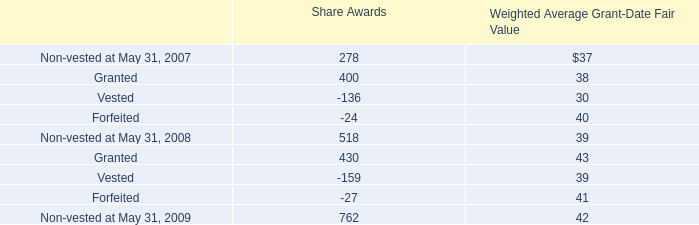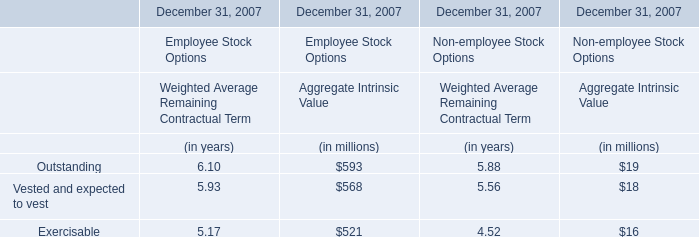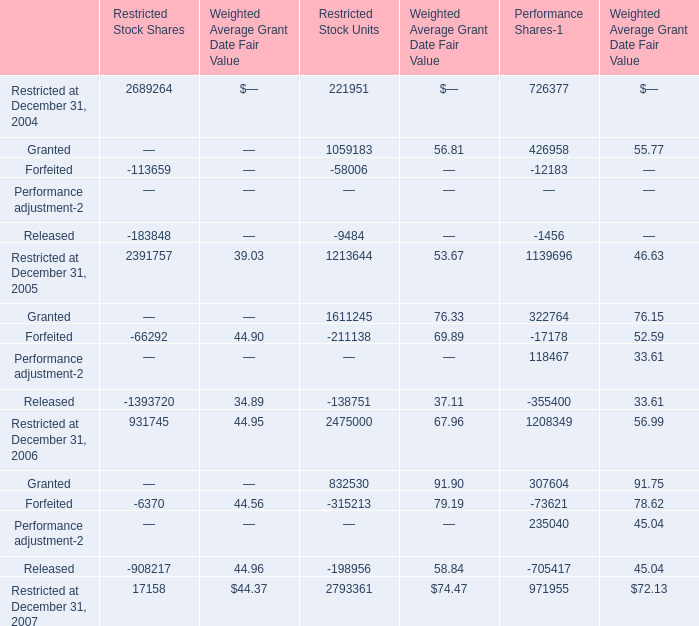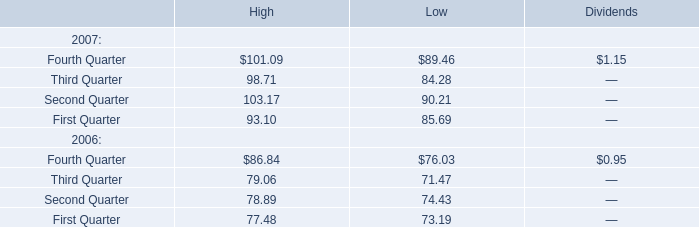what is the total value of non-vested shares as of may 31 , 2008 , ( in millions ) ? 
Computations: ((518 * 39) / 1000)
Answer: 20.202. 